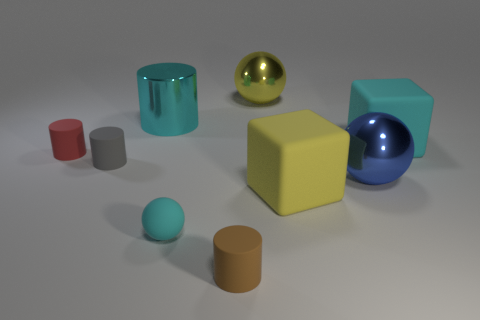Does the small rubber sphere have the same color as the metallic cylinder?
Your response must be concise. Yes. There is a ball that is the same color as the shiny cylinder; what size is it?
Keep it short and to the point. Small. There is a shiny cylinder; are there any tiny gray objects on the right side of it?
Keep it short and to the point. No. Is there a blue metal object on the left side of the matte cylinder to the right of the rubber sphere?
Keep it short and to the point. No. Is the number of cyan metallic cylinders in front of the tiny matte sphere less than the number of tiny rubber spheres that are left of the red matte thing?
Offer a very short reply. No. Is there any other thing that is the same size as the cyan matte ball?
Make the answer very short. Yes. There is a small brown object; what shape is it?
Provide a short and direct response. Cylinder. What is the material of the cube that is behind the large blue metal thing?
Provide a succinct answer. Rubber. How big is the yellow object behind the big cyan thing to the left of the cyan matte thing on the right side of the small brown matte object?
Your response must be concise. Large. Do the block on the right side of the large yellow block and the thing that is left of the small gray thing have the same material?
Provide a succinct answer. Yes. 